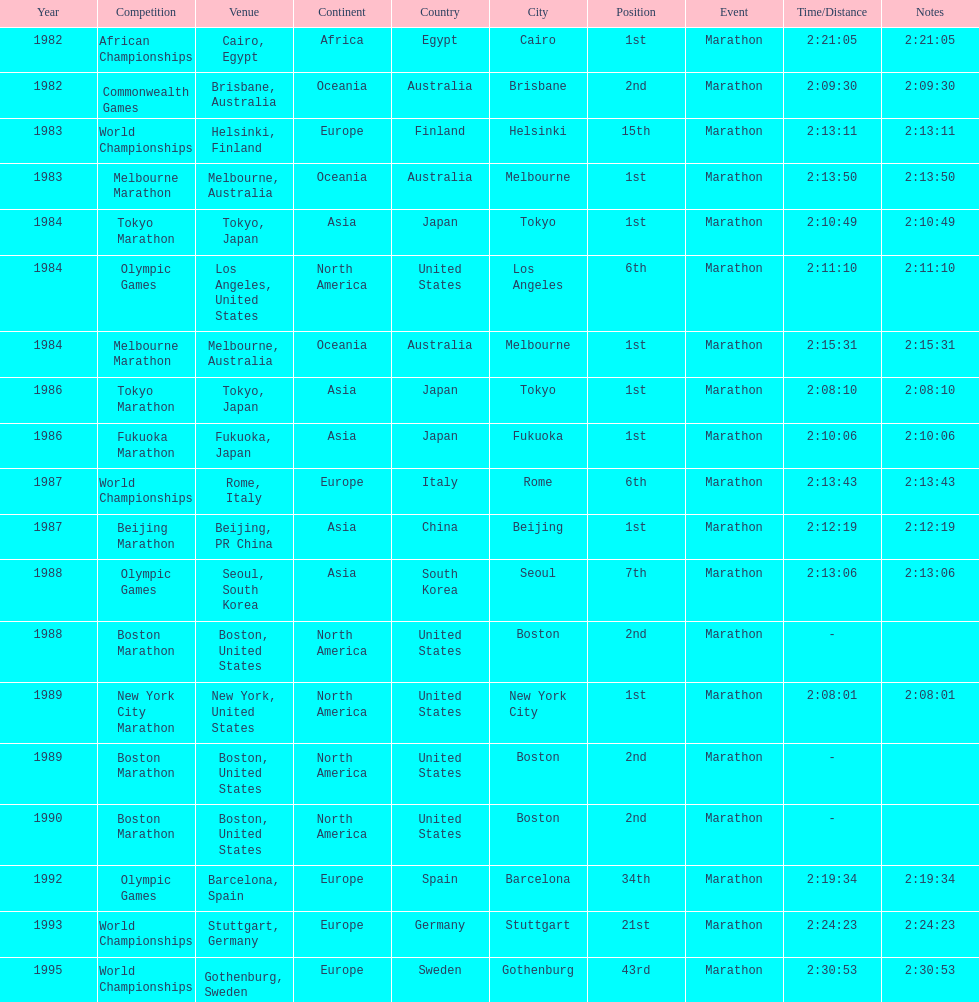Which competition is listed the most in this chart? World Championships. 